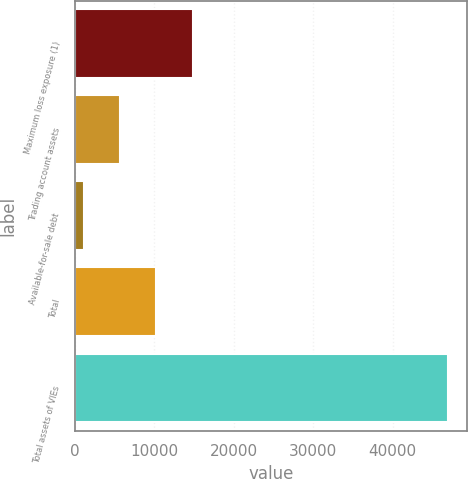Convert chart to OTSL. <chart><loc_0><loc_0><loc_500><loc_500><bar_chart><fcel>Maximum loss exposure (1)<fcel>Trading account assets<fcel>Available-for-sale debt<fcel>Total<fcel>Total assets of VIEs<nl><fcel>14863.2<fcel>5692.4<fcel>1107<fcel>10277.8<fcel>46961<nl></chart> 